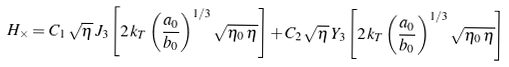Convert formula to latex. <formula><loc_0><loc_0><loc_500><loc_500>H _ { \times } = C _ { 1 } \, \sqrt { \eta } \, J _ { 3 } \left [ 2 \, k _ { T } \left ( \frac { a _ { 0 } } { b _ { 0 } } \right ) ^ { 1 / 3 } \sqrt { \eta _ { 0 } \, \eta } \right ] + C _ { 2 } \, \sqrt { \eta } \, Y _ { 3 } \left [ 2 \, k _ { T } \left ( \frac { a _ { 0 } } { b _ { 0 } } \right ) ^ { 1 / 3 } \sqrt { \eta _ { 0 } \, \eta } \right ]</formula> 